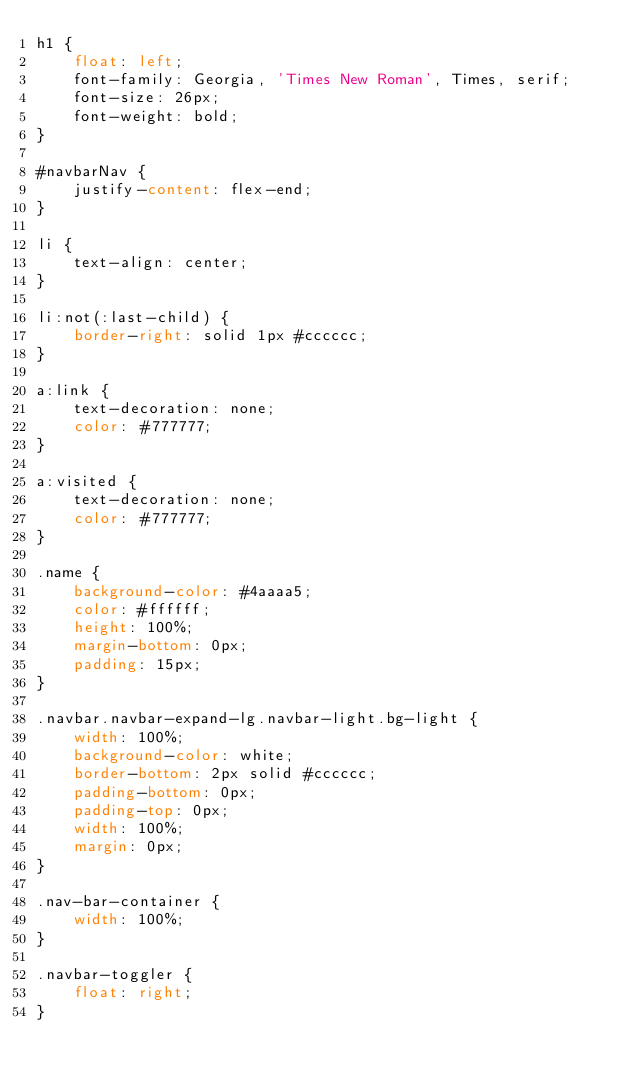Convert code to text. <code><loc_0><loc_0><loc_500><loc_500><_CSS_>h1 {
    float: left;
    font-family: Georgia, 'Times New Roman', Times, serif;
    font-size: 26px;
    font-weight: bold;
}

#navbarNav {
    justify-content: flex-end;
}

li {
    text-align: center;
}

li:not(:last-child) {
    border-right: solid 1px #cccccc;
}

a:link {
    text-decoration: none;
    color: #777777;
}

a:visited {
    text-decoration: none;
    color: #777777;
}

.name {
    background-color: #4aaaa5;
    color: #ffffff;
    height: 100%;
    margin-bottom: 0px;
    padding: 15px;
}

.navbar.navbar-expand-lg.navbar-light.bg-light {
    width: 100%;
    background-color: white;
    border-bottom: 2px solid #cccccc;
    padding-bottom: 0px;
    padding-top: 0px;
    width: 100%;
    margin: 0px;
}

.nav-bar-container {
    width: 100%;
}

.navbar-toggler {
    float: right;
}</code> 